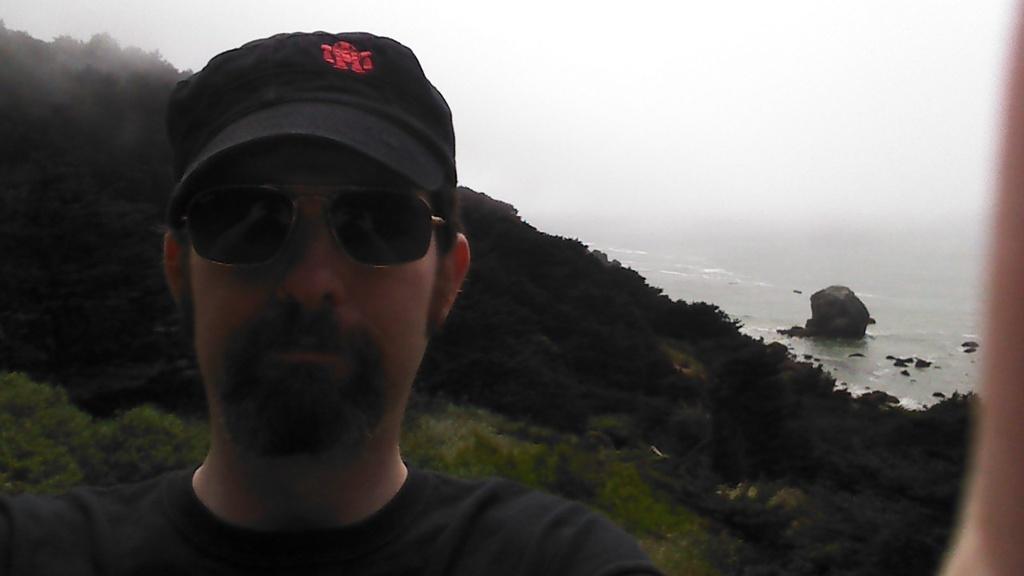Could you give a brief overview of what you see in this image? In this image in the front there is a man wearing goggles and wearing a black colour hat. In the background there are trees and there is water and there are stones and the sky is cloudy. 